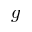<formula> <loc_0><loc_0><loc_500><loc_500>g</formula> 